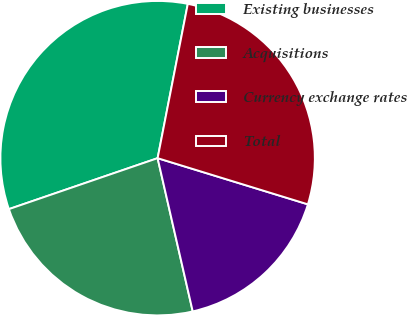Convert chart to OTSL. <chart><loc_0><loc_0><loc_500><loc_500><pie_chart><fcel>Existing businesses<fcel>Acquisitions<fcel>Currency exchange rates<fcel>Total<nl><fcel>33.33%<fcel>23.33%<fcel>16.67%<fcel>26.67%<nl></chart> 